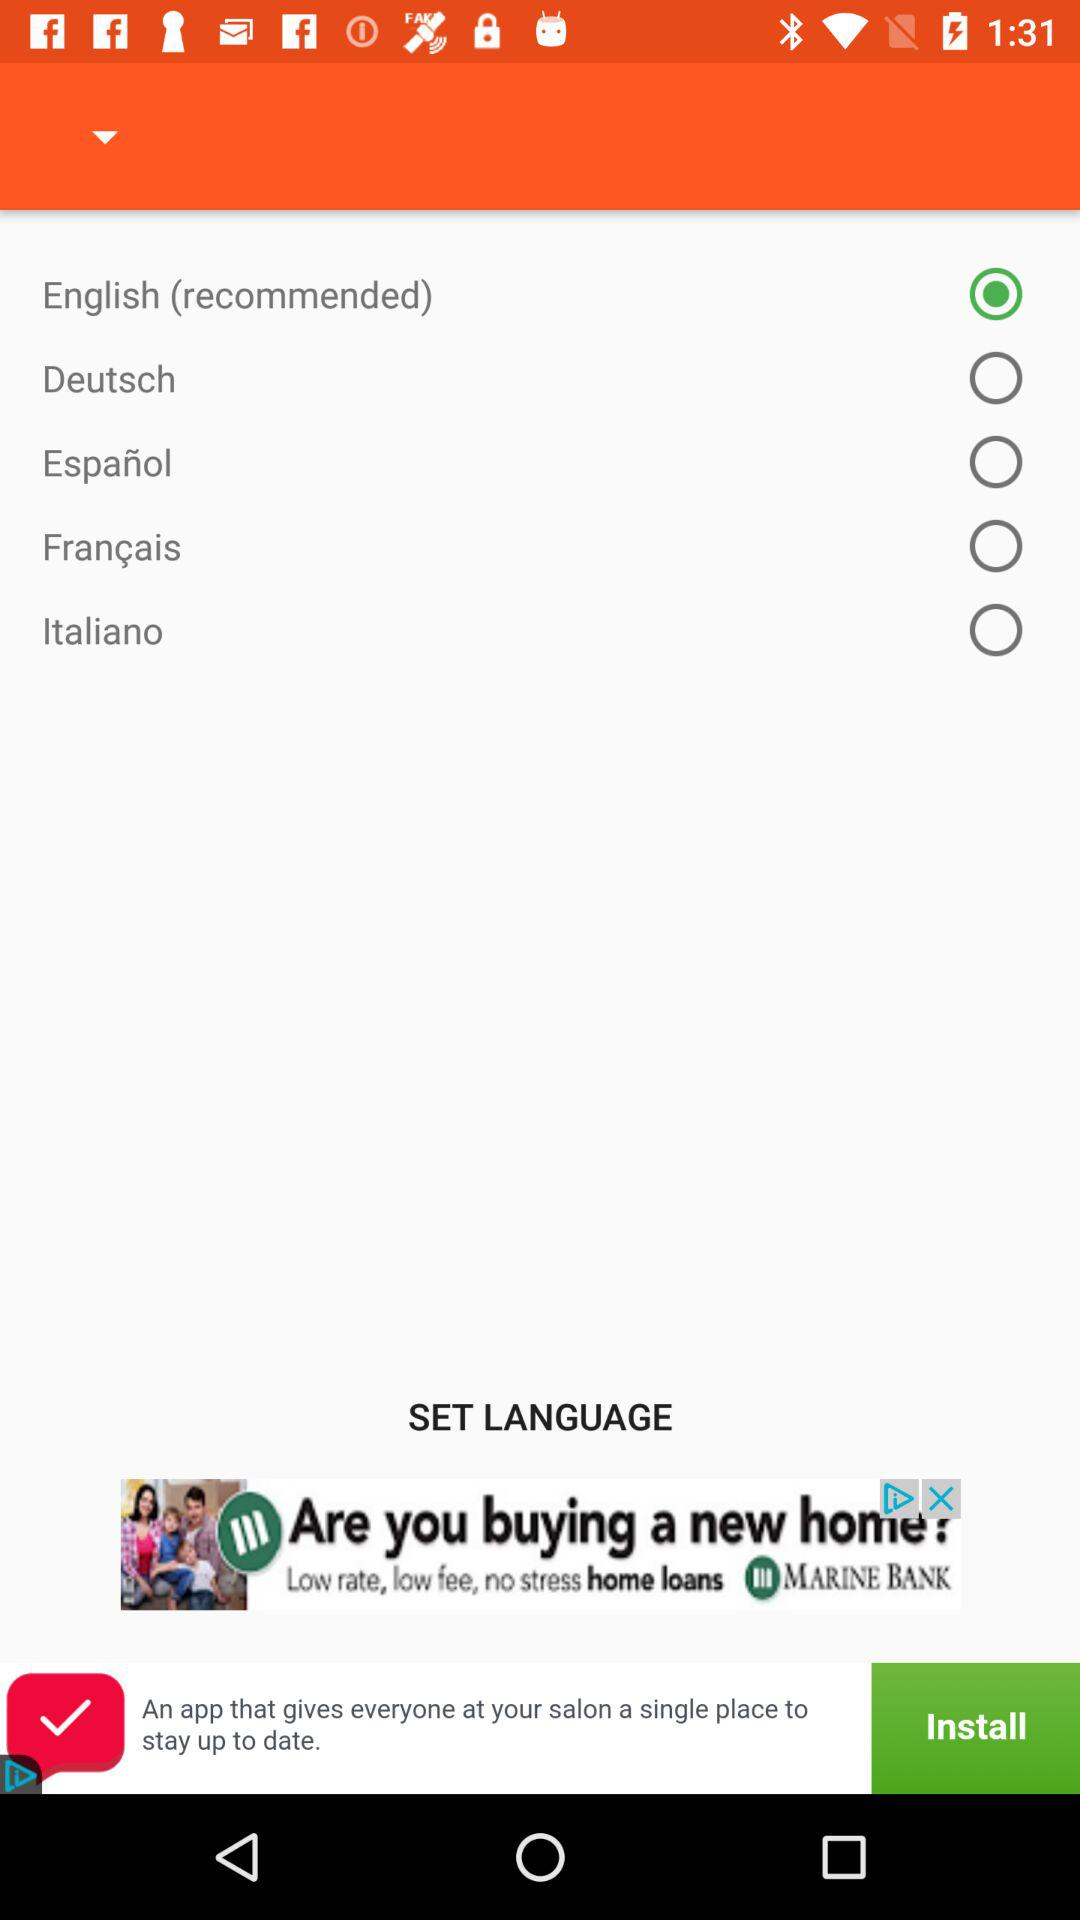Which language is selected? The selected language is English. 